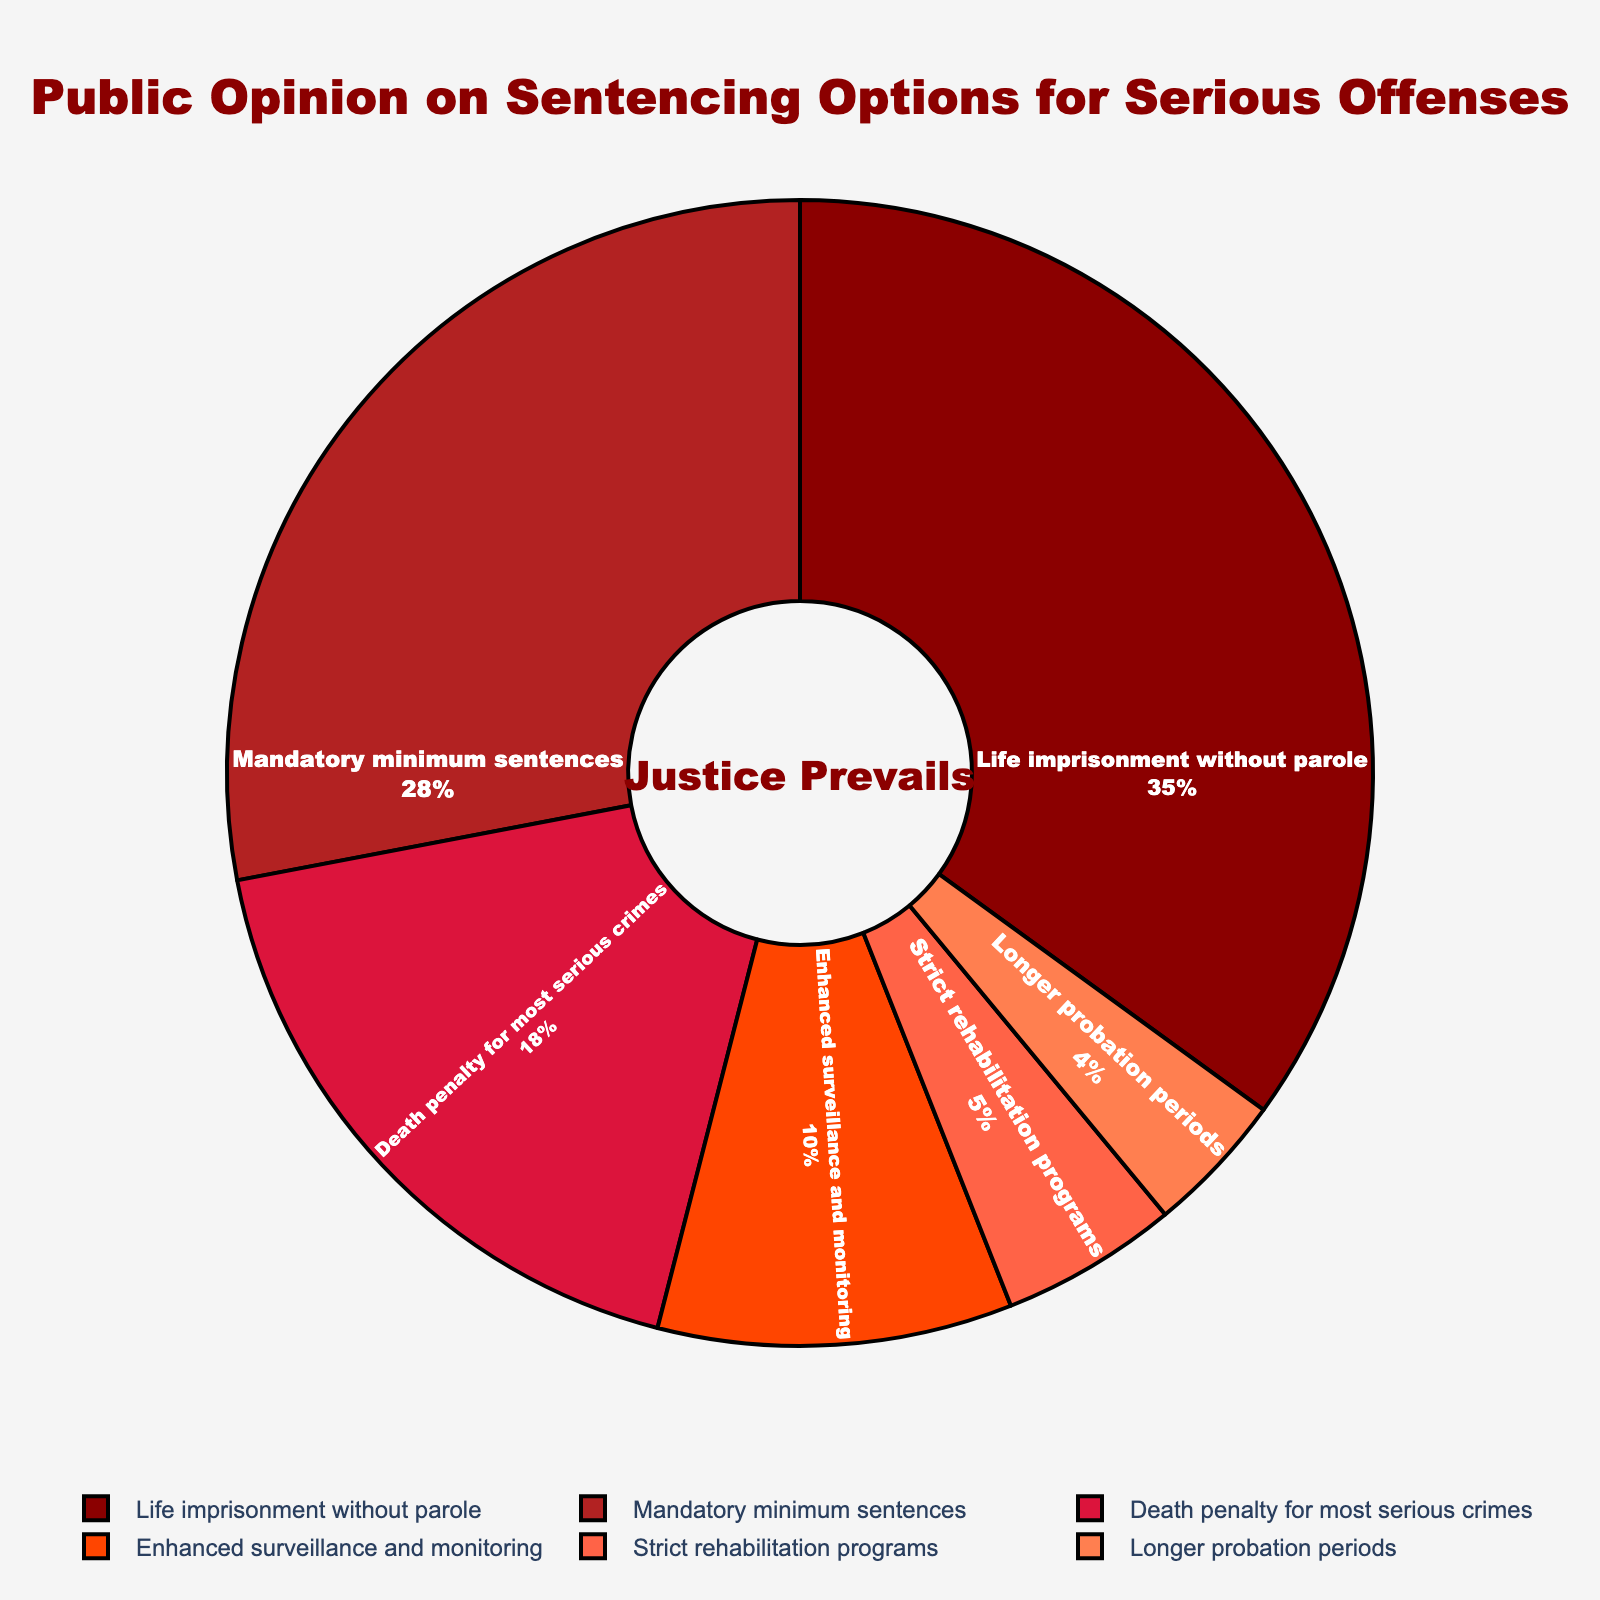What's the majority preference indicated by the pie chart? To determine the majority preference, look for the option with the highest percentage on the pie chart. "Life imprisonment without parole" holds the largest section, which is 35%.
Answer: Life imprisonment without parole Which sentencing option is the least favored according to the chart? Identify the option with the smallest percentage. The smallest section of the pie chart corresponds to "Longer probation periods" with 4%.
Answer: Longer probation periods How much greater is the preference for Mandatory minimum sentences compared to Strict rehabilitation programs? Compare the percentages: "Mandatory minimum sentences" has 28%, and "Strict rehabilitation programs" has 5%. Subtract the latter from the former (28% - 5% = 23%).
Answer: 23% What's the total percentage of people who favor either the Death penalty for most serious crimes or Enhanced surveillance and monitoring? Add the two relevant percentages: 18% for "Death penalty for most serious crimes" and 10% for "Enhanced surveillance and monitoring" (18% + 10% = 28%).
Answer: 28% What is the combined preference percentage for life imprisonment without parole and mandatory minimum sentences? Add the percentages for both options: 35% + 28% = 63%.
Answer: 63% Which options together surpass 50% of the public opinion? Combine different categories until their sum exceeds 50%. "Life imprisonment without parole" (35%) plus "Mandatory minimum sentences" (28%), sum to 63%, which is more than 50%.
Answer: Life imprisonment without parole and mandatory minimum sentences Are there more people who support Enhanced surveillance and monitoring than those who support Longer probation periods? Look at the percentages: "Enhanced surveillance and monitoring" is at 10%, and "Longer probation periods" is at 4%. Since 10% is greater than 4%, the answer is yes.
Answer: Yes Comparing Strict rehabilitation programs and Enhanced surveillance and monitoring, which one has higher public approval and by how much? Compare and subtract their percentages: "Enhanced surveillance and monitoring" at 10% and "Strict rehabilitation programs" at 5%. The difference is 10% - 5% = 5%.
Answer: Enhanced surveillance and monitoring by 5% Which sentencing option's support is closest to 20% of the public opinion? Identify the percentage closest to 20%. "Death penalty for most serious crimes" stands at 18%, which is the closest to 20%.
Answer: Death penalty for most serious crimes 